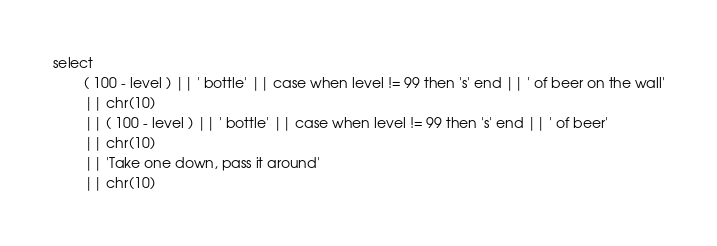Convert code to text. <code><loc_0><loc_0><loc_500><loc_500><_SQL_>select
        ( 100 - level ) || ' bottle' || case when level != 99 then 's' end || ' of beer on the wall'
        || chr(10)
        || ( 100 - level ) || ' bottle' || case when level != 99 then 's' end || ' of beer'
        || chr(10)
        || 'Take one down, pass it around'
        || chr(10)</code> 